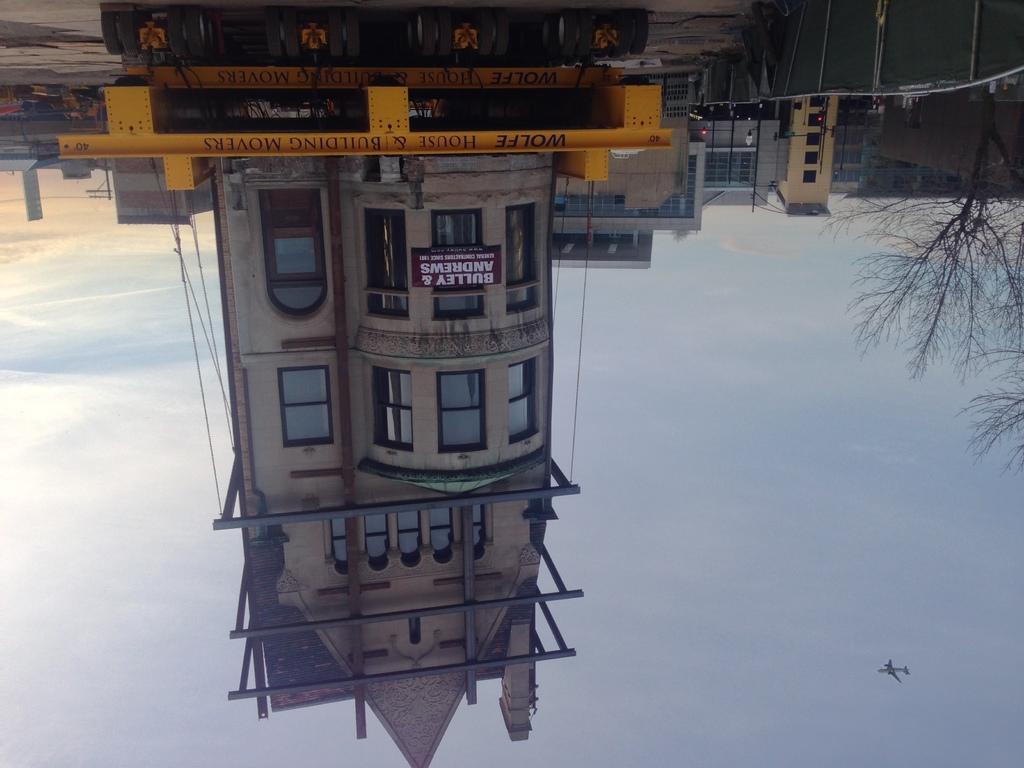Can you describe this image briefly? It is a reverse image where we can see there is a building beside that there are trees and also aeroplane flying in air. 